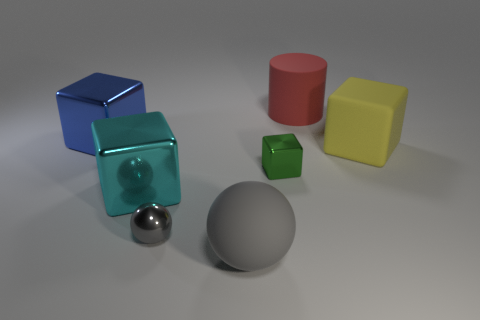There is a object that is the same color as the small metal ball; what is it made of?
Provide a succinct answer. Rubber. Is the color of the large shiny object in front of the big yellow rubber thing the same as the cylinder?
Offer a terse response. No. What is the size of the yellow rubber thing?
Make the answer very short. Large. What material is the red cylinder that is the same size as the blue cube?
Ensure brevity in your answer.  Rubber. There is a large object that is left of the big cyan cube; what color is it?
Provide a short and direct response. Blue. What number of big cyan metal cubes are there?
Your answer should be very brief. 1. There is a big matte object to the right of the matte thing that is behind the yellow matte thing; are there any big cyan metal blocks that are behind it?
Ensure brevity in your answer.  No. There is another object that is the same size as the gray metallic object; what shape is it?
Keep it short and to the point. Cube. What number of other objects are there of the same color as the big cylinder?
Your answer should be very brief. 0. What material is the yellow cube?
Your response must be concise. Rubber. 